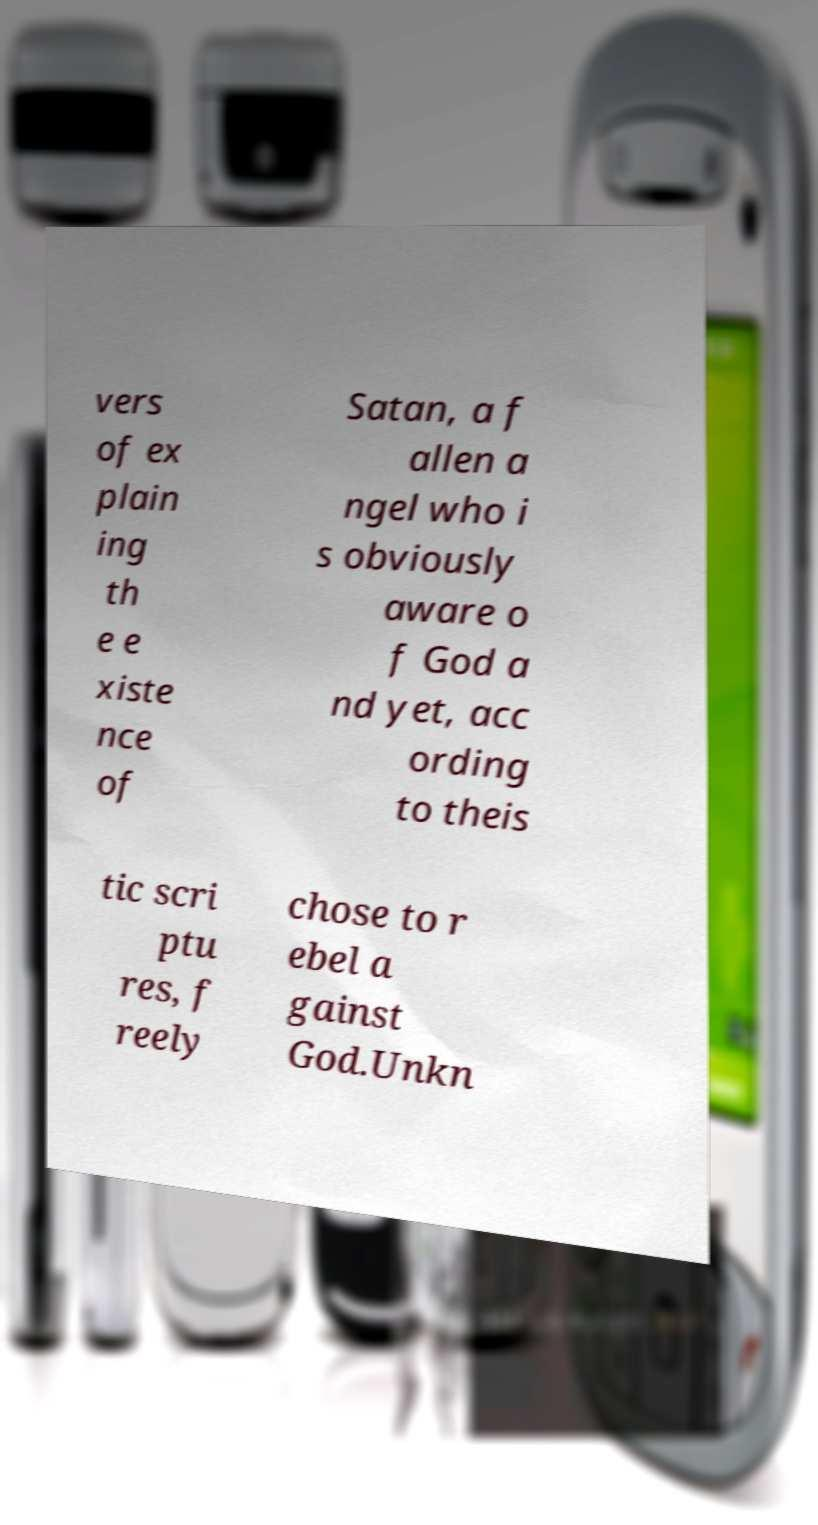I need the written content from this picture converted into text. Can you do that? vers of ex plain ing th e e xiste nce of Satan, a f allen a ngel who i s obviously aware o f God a nd yet, acc ording to theis tic scri ptu res, f reely chose to r ebel a gainst God.Unkn 